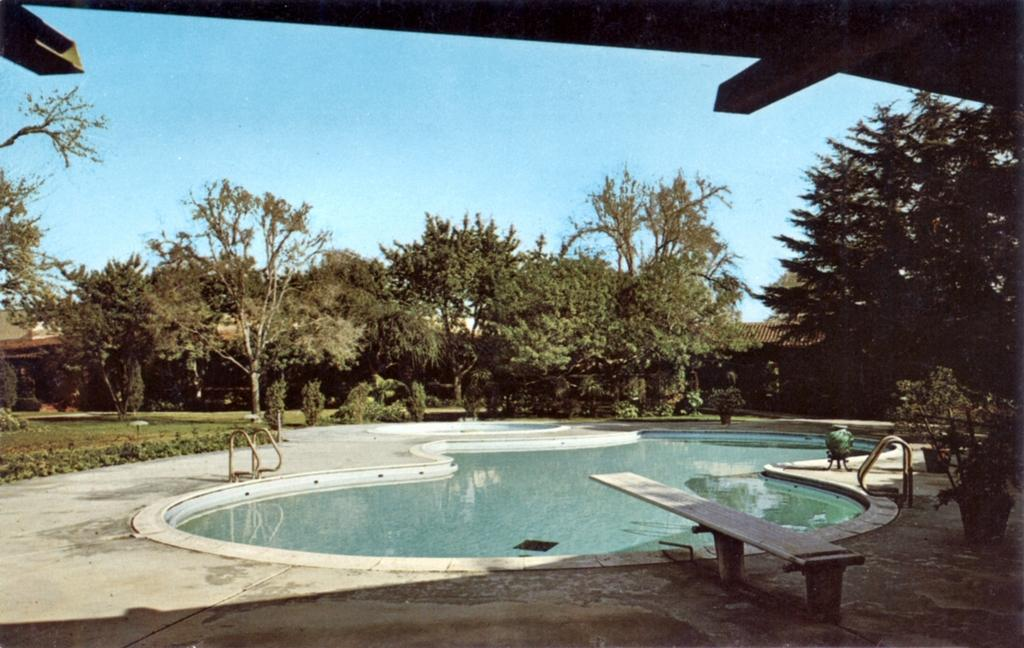What type of water feature is present in the image? There is a swimming pool in the image. What can be used to enter the swimming pool? There is a diving board associated with the swimming pool. What type of vegetation is present in the image? There are plants and trees in the image. What type of ground cover is present in the image? There is grass in the image. What type of structure is present in the image? There is a house in the image. What part of the natural environment is visible in the image? The sky is visible in the image. What type of paint is being used to decorate the ice in the image? There is no ice or paint present in the image. 